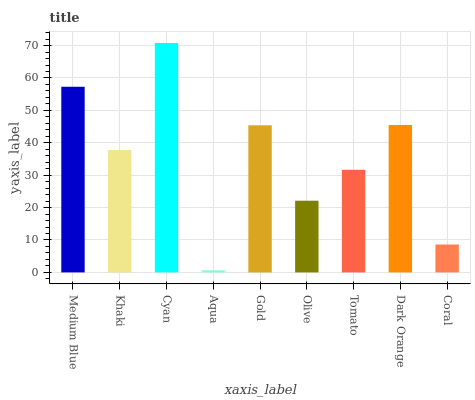Is Aqua the minimum?
Answer yes or no. Yes. Is Cyan the maximum?
Answer yes or no. Yes. Is Khaki the minimum?
Answer yes or no. No. Is Khaki the maximum?
Answer yes or no. No. Is Medium Blue greater than Khaki?
Answer yes or no. Yes. Is Khaki less than Medium Blue?
Answer yes or no. Yes. Is Khaki greater than Medium Blue?
Answer yes or no. No. Is Medium Blue less than Khaki?
Answer yes or no. No. Is Khaki the high median?
Answer yes or no. Yes. Is Khaki the low median?
Answer yes or no. Yes. Is Olive the high median?
Answer yes or no. No. Is Coral the low median?
Answer yes or no. No. 